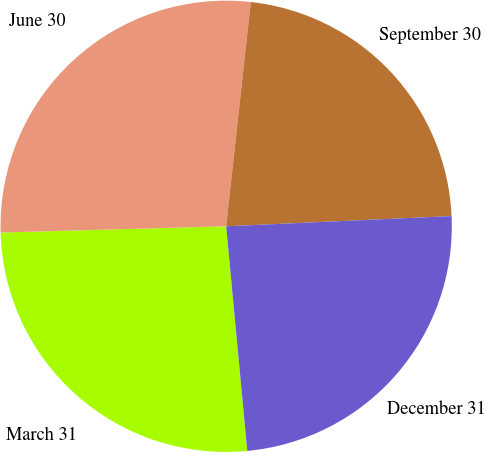Convert chart. <chart><loc_0><loc_0><loc_500><loc_500><pie_chart><fcel>March 31<fcel>June 30<fcel>September 30<fcel>December 31<nl><fcel>26.05%<fcel>27.18%<fcel>22.54%<fcel>24.23%<nl></chart> 